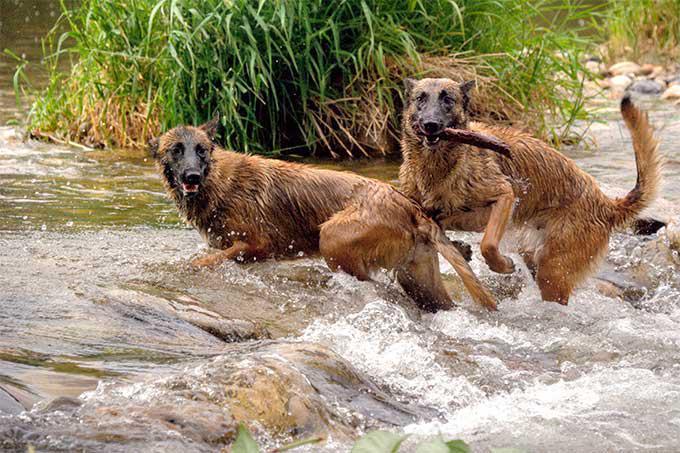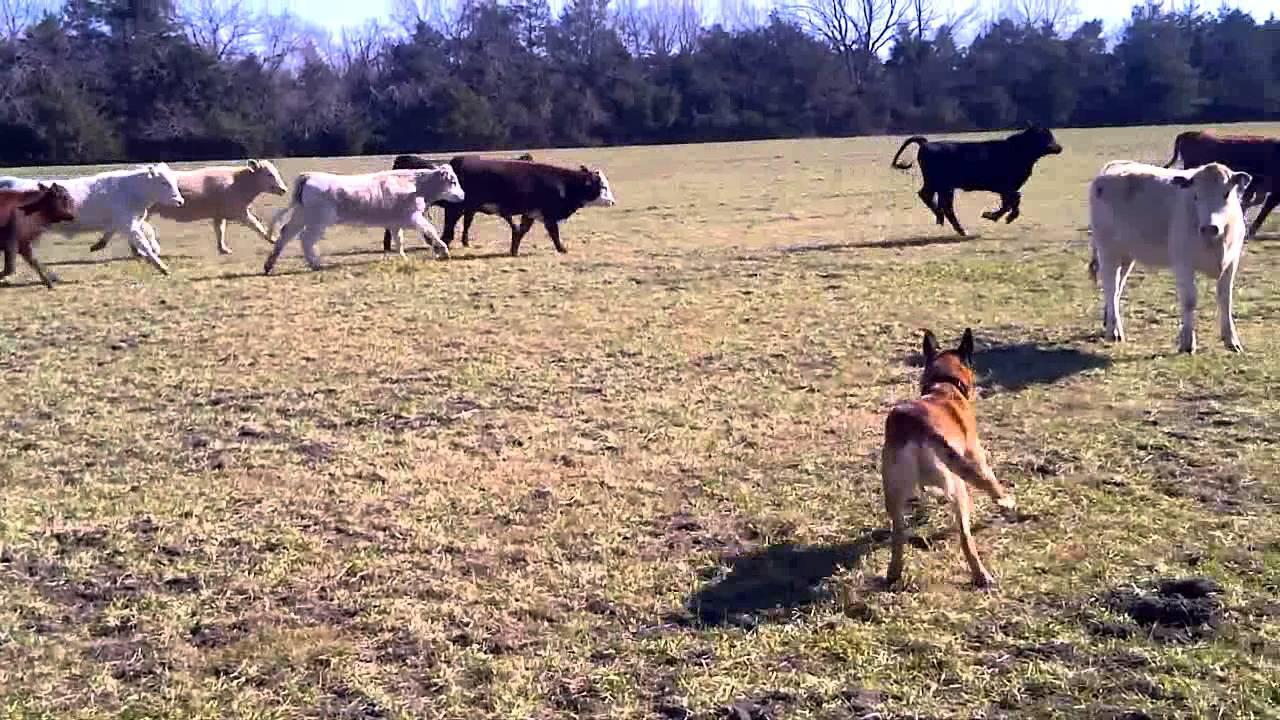The first image is the image on the left, the second image is the image on the right. Examine the images to the left and right. Is the description "In one image, no livestock are present but at least one dog is visible." accurate? Answer yes or no. Yes. The first image is the image on the left, the second image is the image on the right. Analyze the images presented: Is the assertion "All images show a dog with sheep." valid? Answer yes or no. No. 